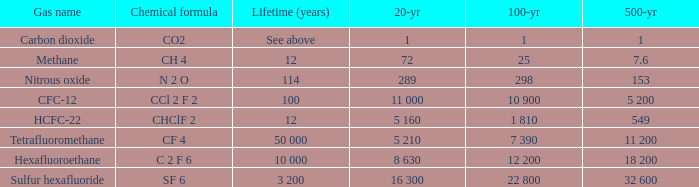What is the 100 year for Carbon Dioxide? 1.0. 